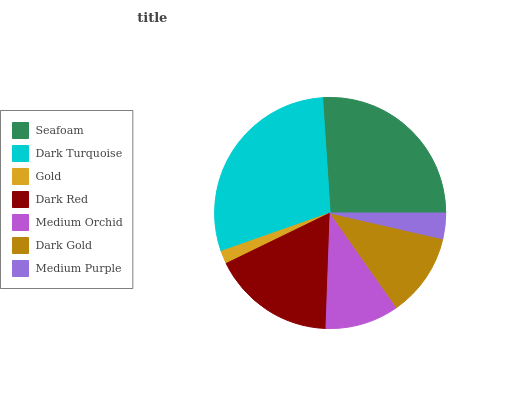Is Gold the minimum?
Answer yes or no. Yes. Is Dark Turquoise the maximum?
Answer yes or no. Yes. Is Dark Turquoise the minimum?
Answer yes or no. No. Is Gold the maximum?
Answer yes or no. No. Is Dark Turquoise greater than Gold?
Answer yes or no. Yes. Is Gold less than Dark Turquoise?
Answer yes or no. Yes. Is Gold greater than Dark Turquoise?
Answer yes or no. No. Is Dark Turquoise less than Gold?
Answer yes or no. No. Is Dark Gold the high median?
Answer yes or no. Yes. Is Dark Gold the low median?
Answer yes or no. Yes. Is Dark Turquoise the high median?
Answer yes or no. No. Is Gold the low median?
Answer yes or no. No. 